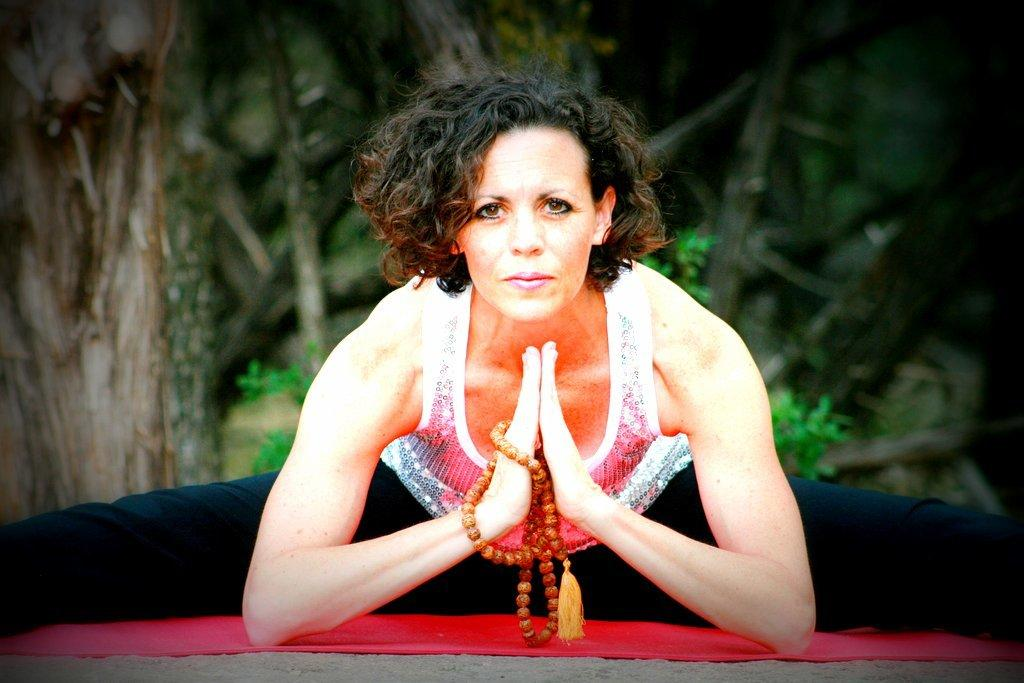Who is the main subject in the image? There is a woman in the image. Where is the woman located in the image? The woman is in the center of the image. What is the woman doing in the image? The woman is doing yoga. What is the woman standing on in the image? There is a red mat in the image, and it is on the ground. What can be seen in the background of the image? There are trees in the background of the image. How many rabbits are hopping around the woman in the image? There are no rabbits present in the image. What is the woman's wish while doing yoga in the image? The image does not provide any information about the woman's wishes or thoughts while doing yoga. 